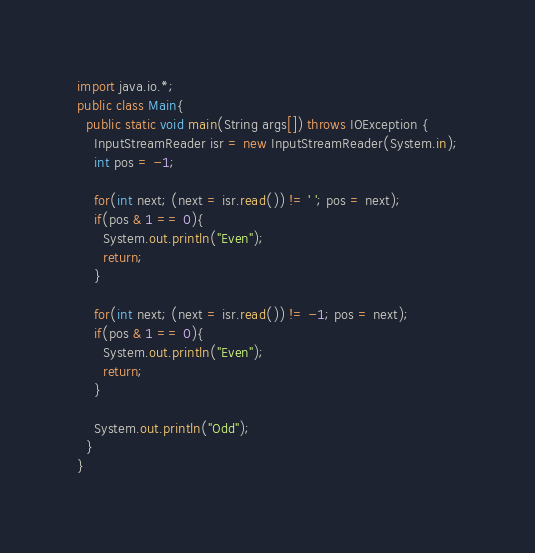<code> <loc_0><loc_0><loc_500><loc_500><_Java_>import java.io.*;
public class Main{
  public static void main(String args[]) throws IOException {
    InputStreamReader isr = new InputStreamReader(System.in);
    int pos = -1;
    
    for(int next; (next = isr.read()) != ' '; pos = next);
    if(pos & 1 == 0){
      System.out.println("Even");
      return;
    }
    
    for(int next; (next = isr.read()) != -1; pos = next);
    if(pos & 1 == 0){
      System.out.println("Even");
      return;
    }
    
    System.out.println("Odd");
  }
}</code> 